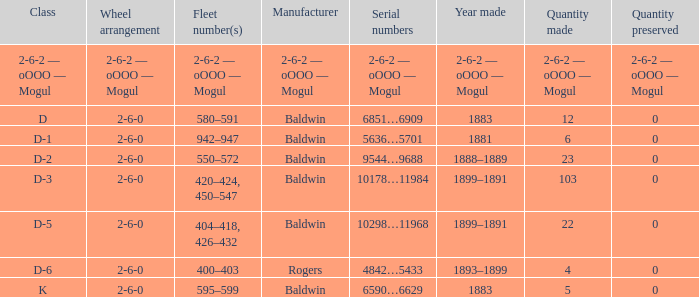What is the year made when the manufacturer is 2-6-2 — oooo — mogul? 2-6-2 — oOOO — Mogul. 